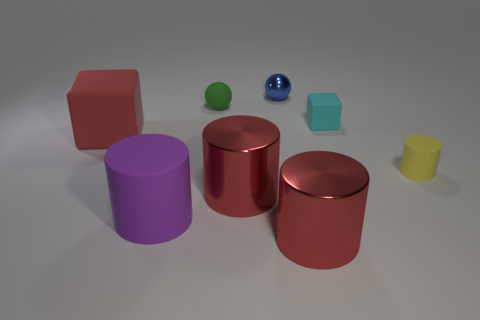Can you tell me the colors of the objects starting from the left? Sure, from the left we have a red cube, a purple cylinder, a red cylinder, a green sphere, a blue sphere, a blue cube, and a yellow cylinder. 